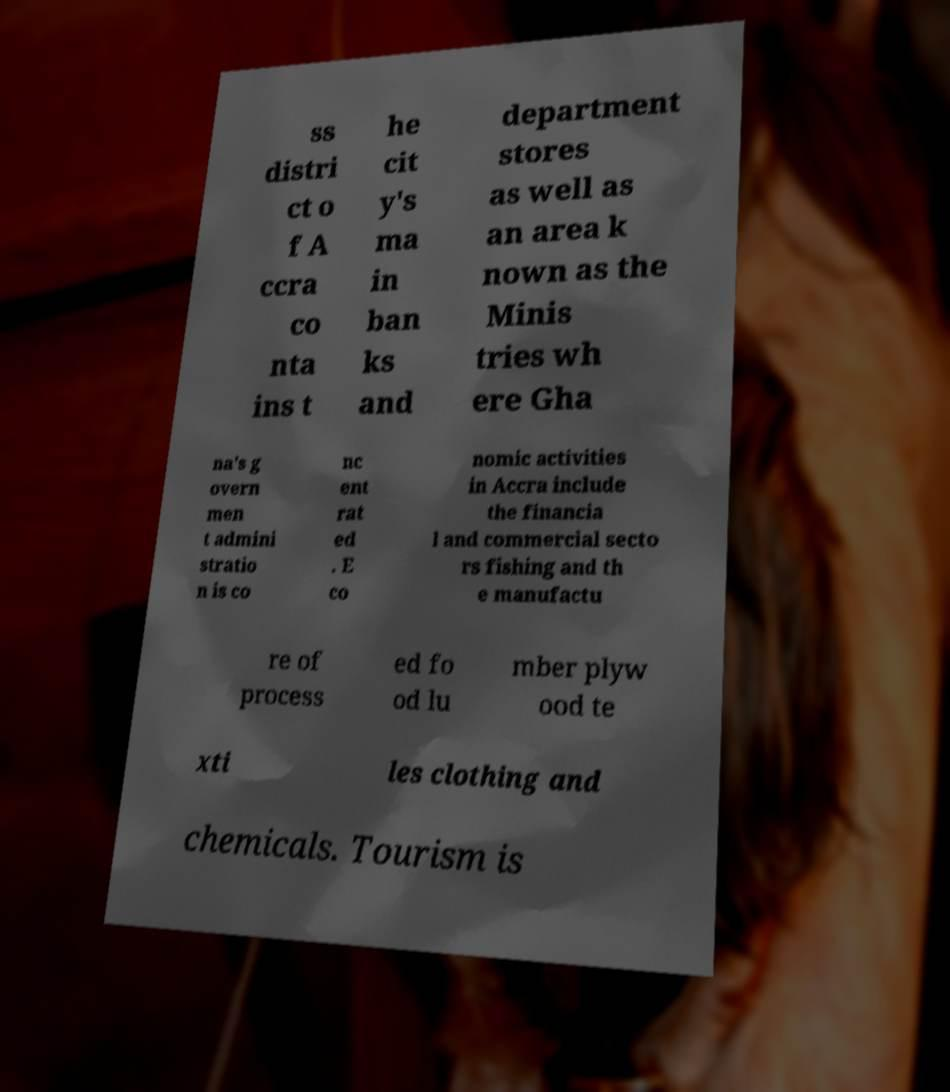For documentation purposes, I need the text within this image transcribed. Could you provide that? ss distri ct o f A ccra co nta ins t he cit y's ma in ban ks and department stores as well as an area k nown as the Minis tries wh ere Gha na's g overn men t admini stratio n is co nc ent rat ed . E co nomic activities in Accra include the financia l and commercial secto rs fishing and th e manufactu re of process ed fo od lu mber plyw ood te xti les clothing and chemicals. Tourism is 